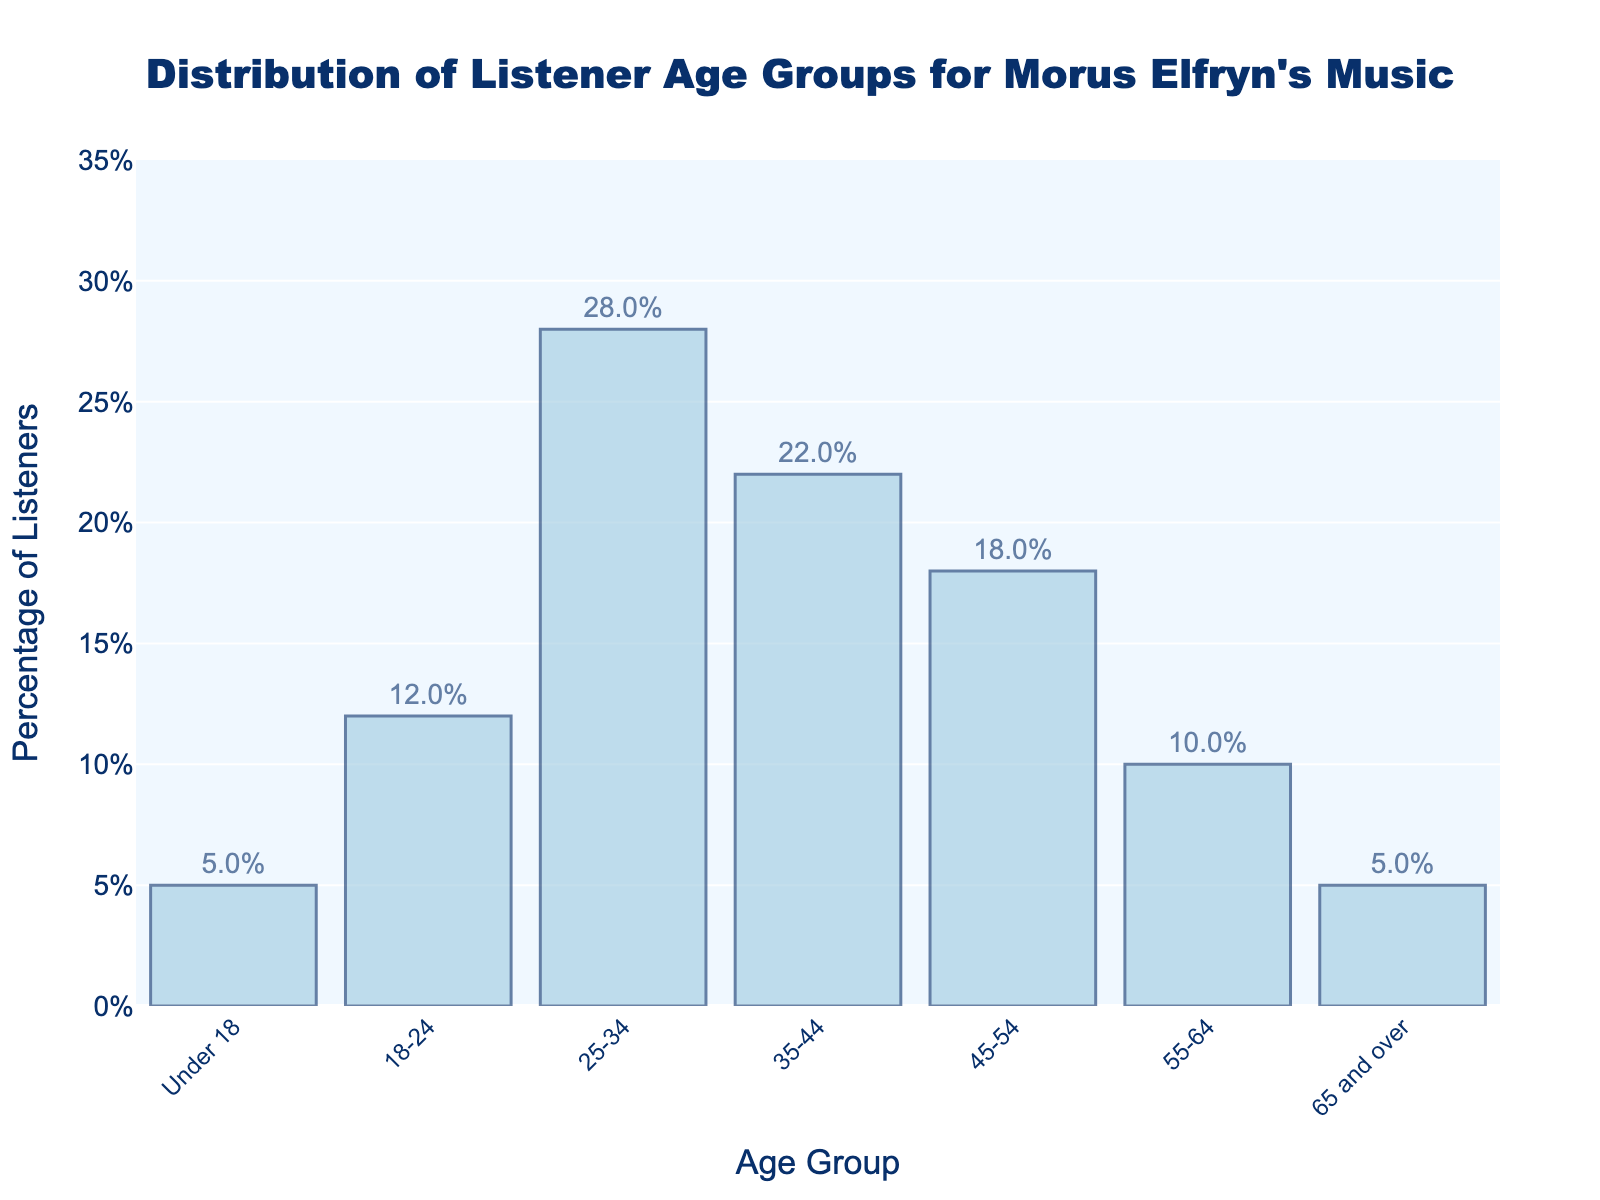What's the most common age group of listeners for Morus Elfryn's music? The group with the highest percentage of listeners is indicated as the tallest bar on the chart. The 25-34 age group has the tallest bar, representing 28% of listeners.
Answer: 25-34 Which age group has the least percentage of listeners for Morus Elfryn's music? The shortest bars indicate the groups with the least percentage of listeners. Both the Under 18 and 65 and over age groups have bars of equal height, representing the smallest percentage at 5%.
Answer: Under 18 and 65 and over How much higher is the percentage of listeners in the 25-34 age group compared to the 55-64 age group? The percentage for the 25-34 age group is 28%, and for the 55-64 age group is 10%. The difference is calculated by subtracting 10% from 28%, which is 18%.
Answer: 18% What is the combined percentage of listeners in the 35-44 and 45-54 age groups? Add the percentages for the 35-44 and 45-54 age groups: 22% + 18% = 40%.
Answer: 40% Which age group contributes more to the listener percentage: the 18-24 age group or the 45-54 age group? Compare the bars' heights for the 18-24 and 45-54 age groups. The 45-54 age group has 18%, whereas the 18-24 age group has 12%.
Answer: 45-54 What is the average percentage of the listener age groups from Under 18 to 35-44? Calculate the average by adding the percentages for Under 18, 18-24, 25-34, and 35-44, then divide by the number of groups: (5 + 12 + 28 + 22) / 4 = 16.75%.
Answer: 16.75% How does the percentage of under 18 listeners compare to the percentage of listeners aged 55-64? The percentage of listeners Under 18 is 5%, while those aged 55-64 is 10%. The 55-64 group has exactly double the percentage of the Under 18 group.
Answer: 55-64 What is the ratio of listeners aged 25-34 to those aged 65 and over? The percentage for the 25-34 age group is 28%, while for the 65 and over group, it's 5%. The ratio is 28:5.
Answer: 28:5 